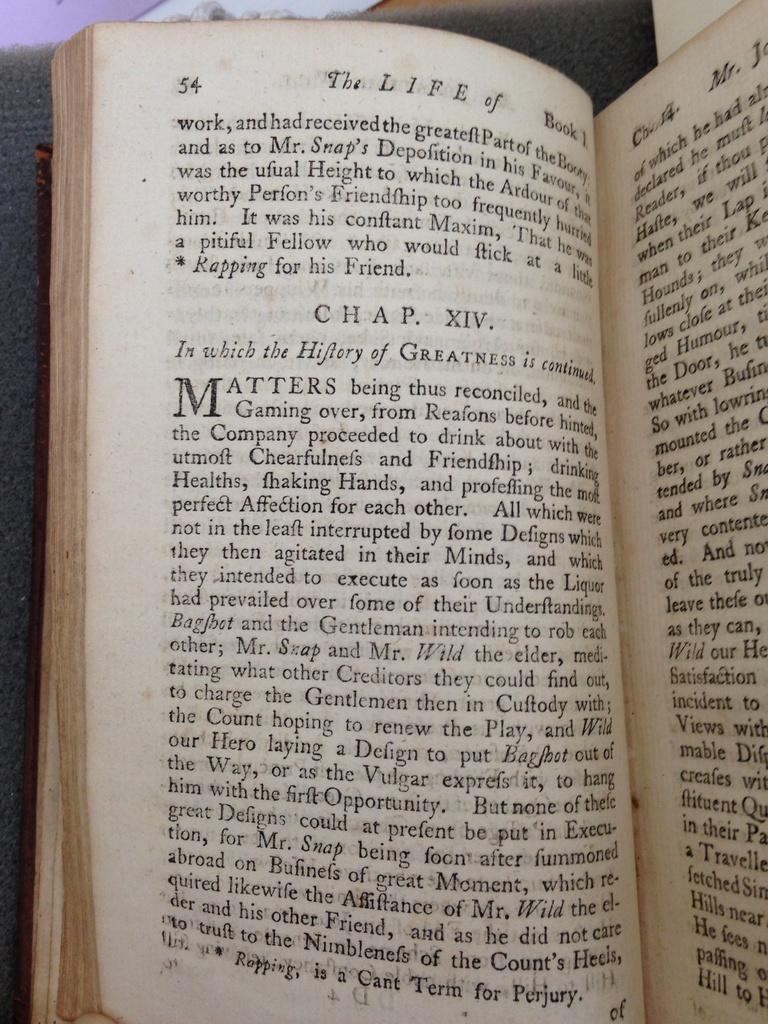What's the title of the book at the top?
Provide a succinct answer. The life of. What chapter is this reader starting?
Make the answer very short. Xiv. 